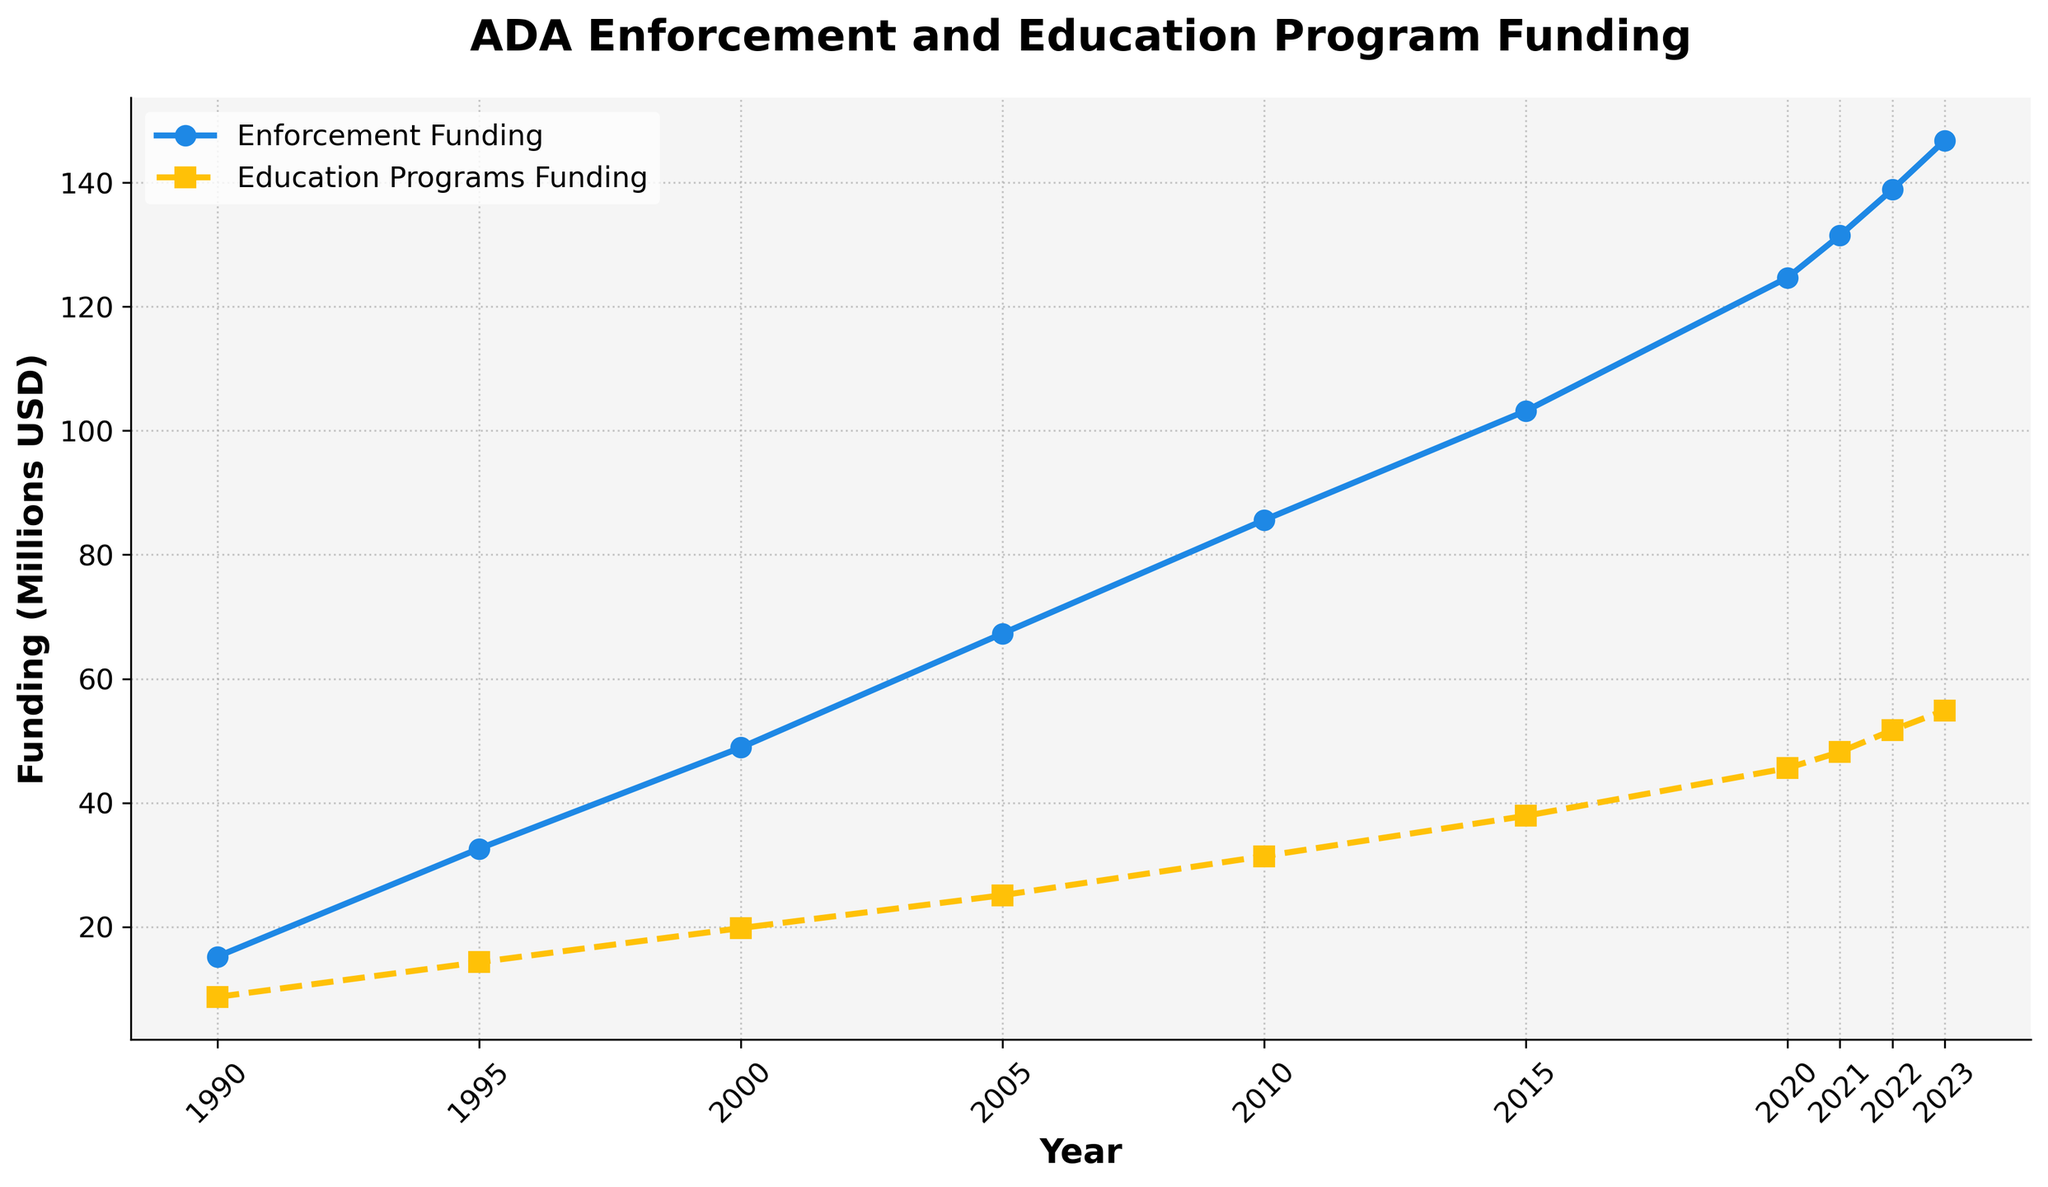What is the difference in enforcement funding between 1990 and 2023? To find the difference in enforcement funding between 1990 and 2023, subtract the 1990 value from the 2023 value: 146.8 - 15.2 = 131.6 million USD.
Answer: 131.6 million USD Which year shows the highest funding for education programs? By looking at the plotted data, the year with the highest education programs funding is the one with the highest plotted point on the education programs funding line, which is 2023 with 54.9 million USD.
Answer: 2023 How many years did it take for both enforcement and education program funding to double from their 1990 values? Doubling the 1990 values gives us 30.4 million USD for enforcement funding and 17.4 million USD for education programs funding. For enforcement, this level is reached between 1990 and 1995. For education, the level is reached between 1990 and 1995 as well. Therefore, it took about 5 years for both to double.
Answer: 5 years In which years did the education programs funding surpass 30 million USD? By observing the plotted data, the education programs funding surpasses 30 million USD in 2010 and continues to be above 30 million USD in subsequent years.
Answer: 2010, 2015, 2020, 2021, 2022, 2023 What is the average enforcement funding over the entire period? To find the average, sum up the enforcement funding values and divide by the number of years: (15.2 + 32.6 + 48.9 + 67.3 + 85.6 + 103.2 + 124.7 + 131.5 + 138.9 + 146.8) / 10 = 89.47 million USD.
Answer: 89.47 million USD Compare the growth trend between enforcement funding and education program funding from 1990 to 2023. From the plotted data, we see both funding types exhibit an increasing trend. Enforcement funding shows steeper growth as it starts from 15.2 million USD in 1990 and reaches 146.8 million USD in 2023, while education funding starts at 8.7 million USD and increases to 54.9 million USD in the same period. Thus, enforcement funding has a higher growth rate compared to education funding.
Answer: Enforcement funding has a higher growth rate than education funding By how much did enforcement funding increase from 2000 to 2020? Subtract the 2000 value from the 2020 value for enforcement funding: 124.7 - 48.9 = 75.8 million USD.
Answer: 75.8 million USD What visual style is used to differentiate between enforcement and education funding lines in the chart? The enforcement funding line is represented with solid lines and circles, while the education funding line is represented with dashed lines and squares. These visual styles make it easier to distinguish between the two lines.
Answer: Solid lines with circles for enforcement funding, dashed lines with squares for education funding Which funding type had a more consistent growth over the observed period? By inspecting the plotted lines, enforcement funding has a more consistent and steady growth, as it continuously increases each year without any significant fluctuation. Education funding also grows steadily but shows a slightly less consistent pattern compared to enforcement funding.
Answer: Enforcement funding has more consistent growth 